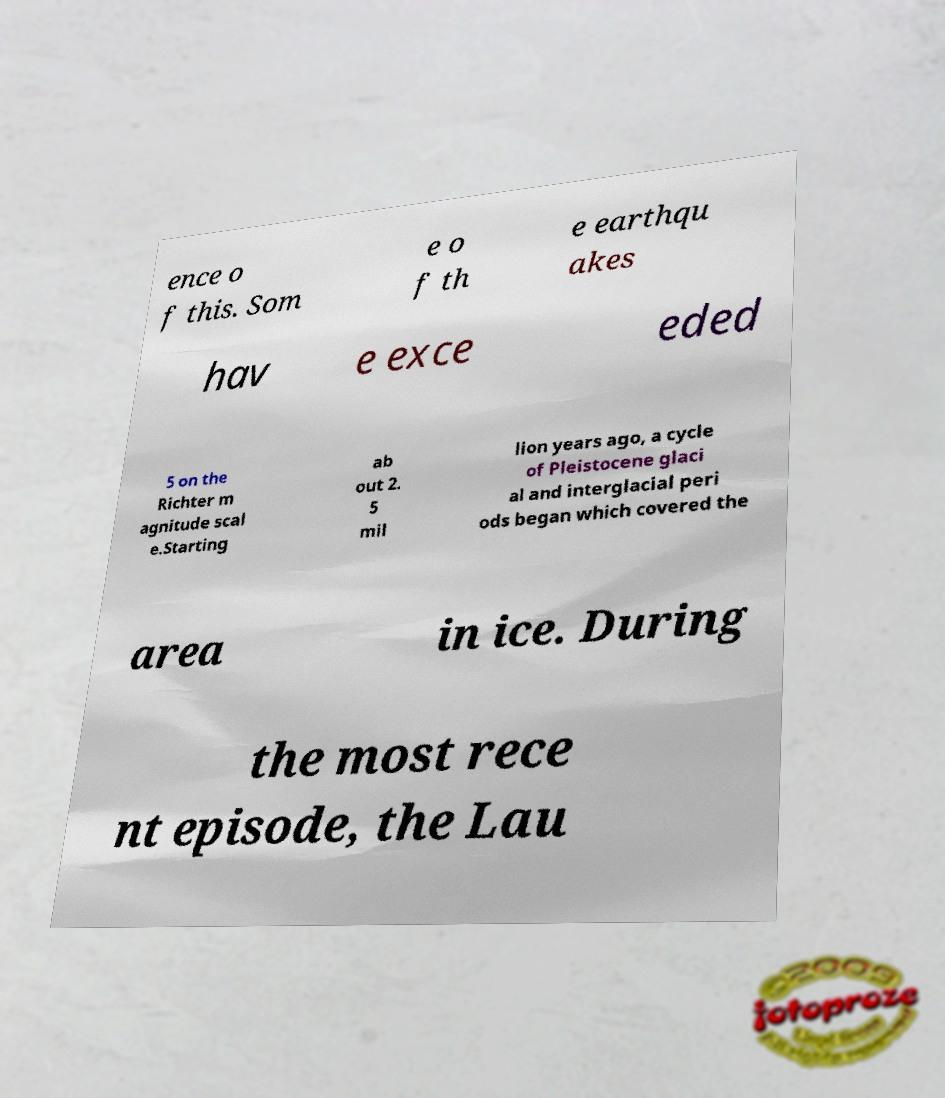Please read and relay the text visible in this image. What does it say? ence o f this. Som e o f th e earthqu akes hav e exce eded 5 on the Richter m agnitude scal e.Starting ab out 2. 5 mil lion years ago, a cycle of Pleistocene glaci al and interglacial peri ods began which covered the area in ice. During the most rece nt episode, the Lau 